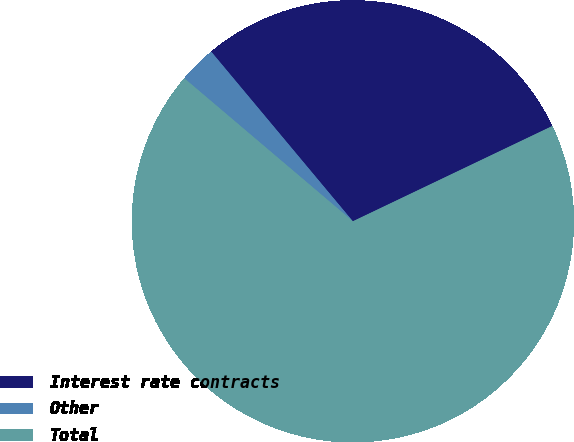<chart> <loc_0><loc_0><loc_500><loc_500><pie_chart><fcel>Interest rate contracts<fcel>Other<fcel>Total<nl><fcel>28.98%<fcel>2.73%<fcel>68.29%<nl></chart> 